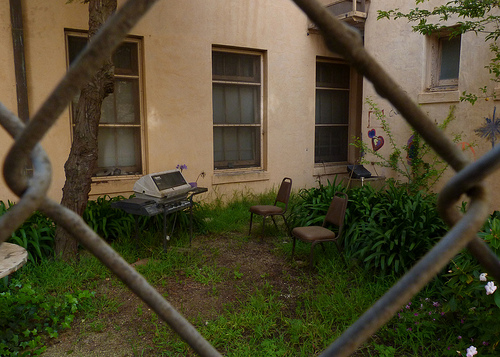<image>
Is the chair next to the gas grill? Yes. The chair is positioned adjacent to the gas grill, located nearby in the same general area. 